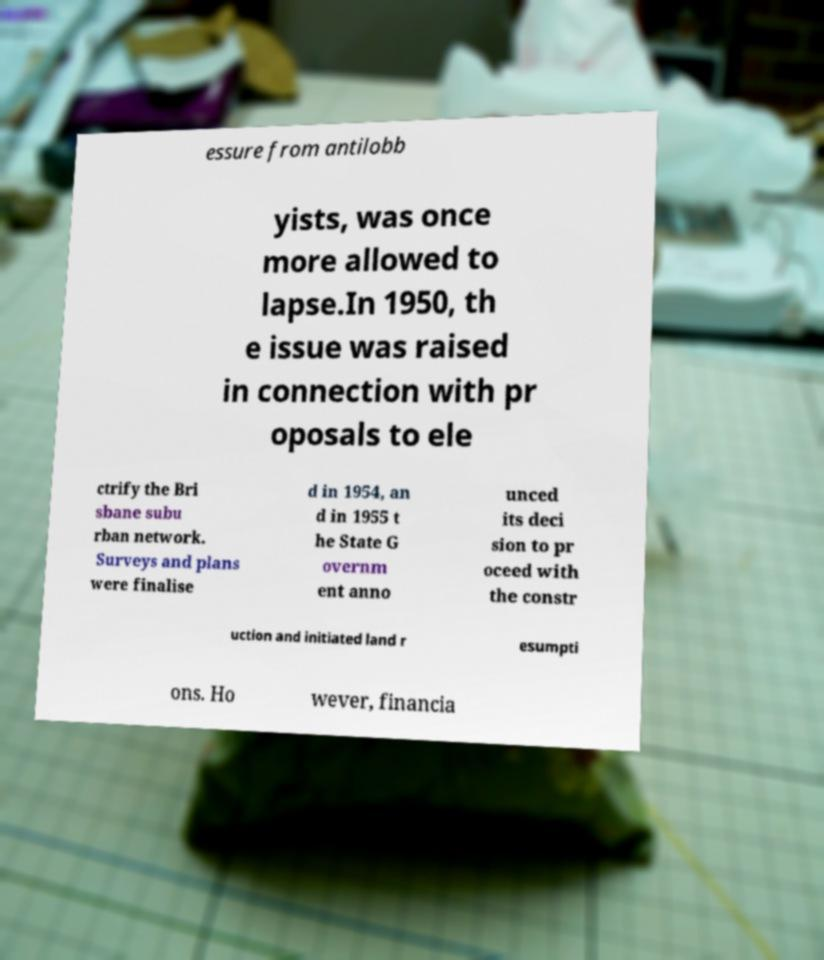For documentation purposes, I need the text within this image transcribed. Could you provide that? essure from antilobb yists, was once more allowed to lapse.In 1950, th e issue was raised in connection with pr oposals to ele ctrify the Bri sbane subu rban network. Surveys and plans were finalise d in 1954, an d in 1955 t he State G overnm ent anno unced its deci sion to pr oceed with the constr uction and initiated land r esumpti ons. Ho wever, financia 